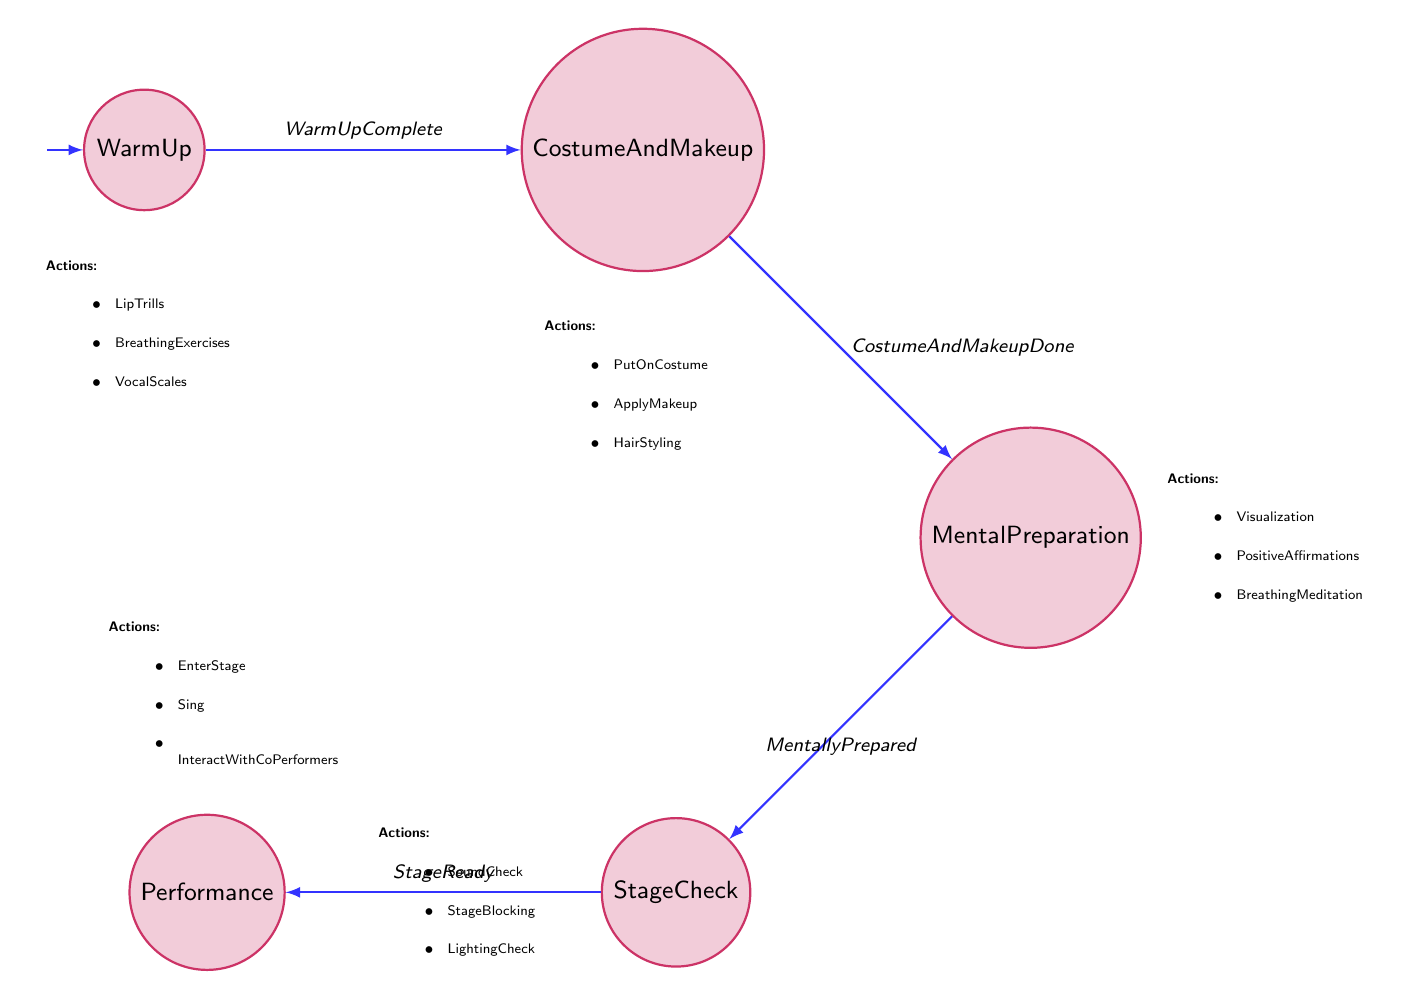What's the first state in the diagram? The first state listed in the diagram is "WarmUp," as it is identified as the initial state from which all transitions begin.
Answer: WarmUp How many actions are listed under the "Costume and Makeup" state? The "Costume and Makeup" state has three actions listed: "PutOnCostume," "ApplyMakeup," and "HairStyling," making a total of three.
Answer: 3 What is the condition for transitioning from "Stage Check" to "Performance"? The transition condition from "Stage Check" to "Performance" is labeled as "StageReady," which indicates that this condition must be satisfied to make the transition.
Answer: StageReady Which state follows "WarmUp"? The state that follows "WarmUp" is "Costume and Makeup." This is determined by the transition labeled "WarmUpComplete," which connects these two states.
Answer: Costume and Makeup What are the three actions in the "Mental Preparation" state? The "Mental Preparation" state includes the following three actions: "Visualization," "PositiveAffirmations," and "BreathingMeditation." These actions are explicitly listed under that state.
Answer: Visualization, PositiveAffirmations, BreathingMeditation What is the last state before "Performance"? The last state before "Performance" is "Stage Check." This state leads directly into "Performance" through the transition called "StageReady."
Answer: Stage Check How many total states are in the diagram? There are five states in total within the diagram, which include "WarmUp," "Costume and Makeup," "Mental Preparation," "Stage Check," and "Performance."
Answer: 5 What action is associated with the “Performance” state? The actions associated with the "Performance" state include "EnterStage," "Sing," and "InteractWithCoPerformers," which are the activities designated for that state in the diagram.
Answer: EnterStage, Sing, InteractWithCoPerformers What must be completed before moving to "Mental Preparation"? Before moving to "Mental Preparation," the condition of "CostumeAndMakeupDone" must be completed, following the transition from "Costume and Makeup."
Answer: CostumeAndMakeupDone 